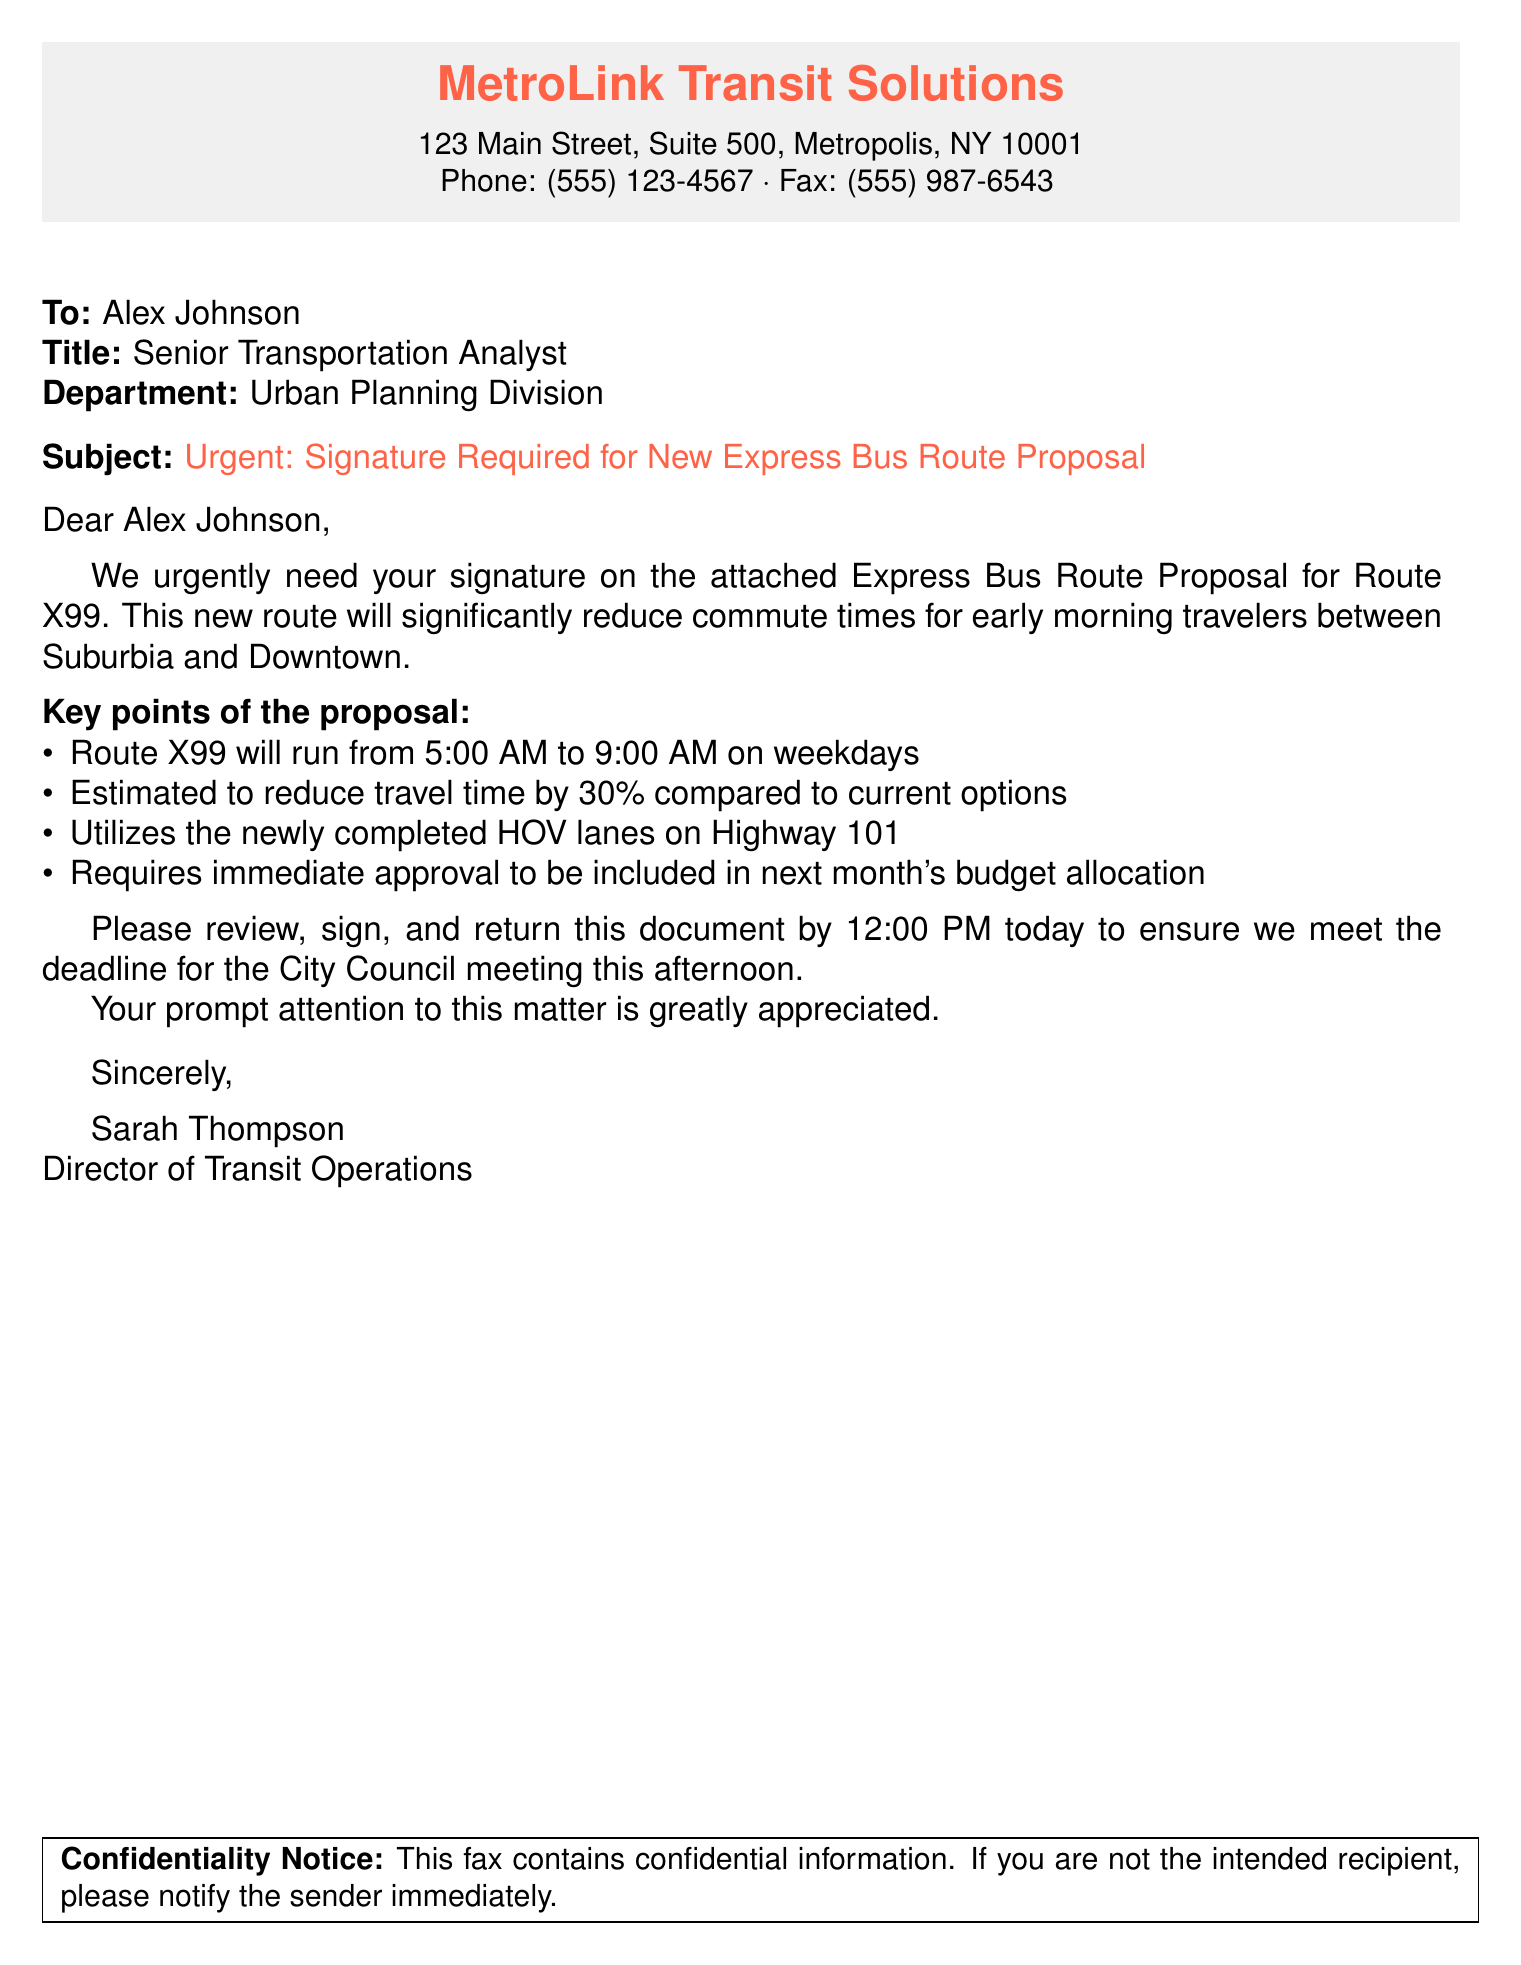What is the name of the organization sending the fax? The organization sending the fax is identified in the header of the document.
Answer: MetroLink Transit Solutions Who is the intended recipient of the fax? The intended recipient is mentioned in the "To" section of the document.
Answer: Alex Johnson What is the subject of the fax? The subject is clearly stated and highlights the urgency of the document.
Answer: Urgent: Signature Required for New Express Bus Route Proposal What is the proposed route number mentioned in the document? The proposed route number appears in the subject line and body of the fax.
Answer: X99 How much is the estimated reduction in travel time? The estimated reduction in travel time is specified in the key points of the proposal.
Answer: 30% What is the deadline for returning the signed document? The deadline for returning the signed document is stated in the closing remarks.
Answer: 12:00 PM today What is the purpose of Route X99? The purpose of Route X99 is outlined in the body of the document.
Answer: Reduce commute times for early morning travelers Which highway will the new route utilize? The highway mentioned in the proposal is specified in the key points.
Answer: Highway 101 What is the job title of the sender? The sender's job title is mentioned in the closing signature section of the letter.
Answer: Director of Transit Operations 